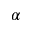Convert formula to latex. <formula><loc_0><loc_0><loc_500><loc_500>\alpha</formula> 